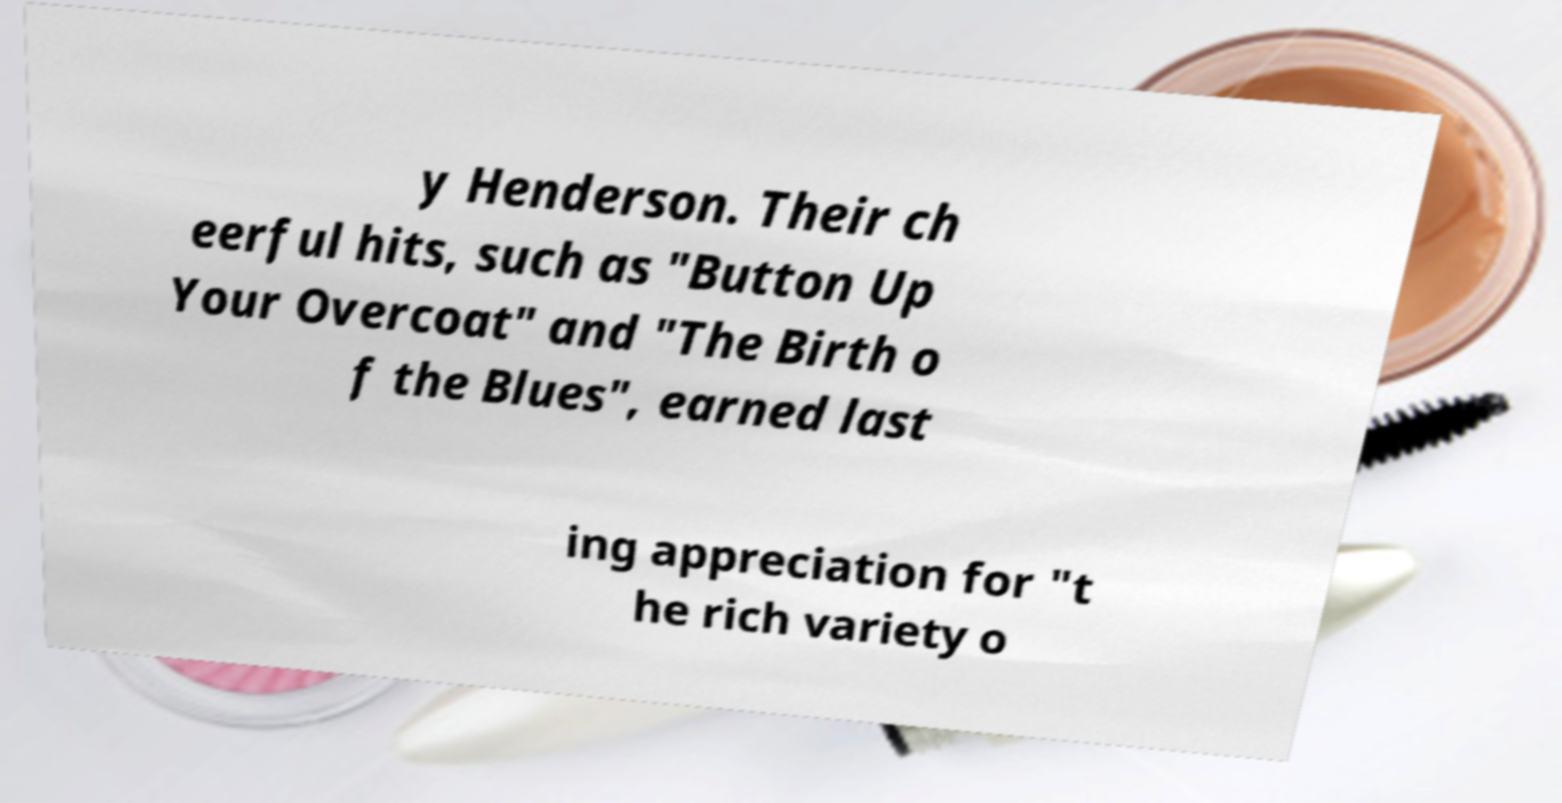Could you extract and type out the text from this image? y Henderson. Their ch eerful hits, such as "Button Up Your Overcoat" and "The Birth o f the Blues", earned last ing appreciation for "t he rich variety o 